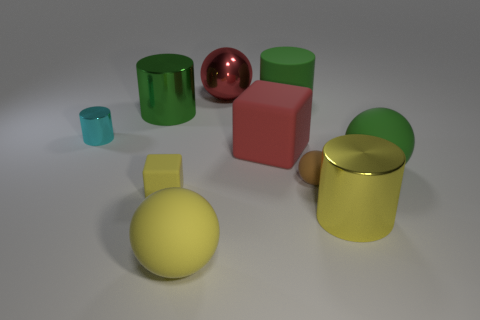Subtract 2 cylinders. How many cylinders are left? 2 Subtract all blue cylinders. Subtract all blue balls. How many cylinders are left? 4 Subtract all cubes. How many objects are left? 8 Add 4 tiny yellow objects. How many tiny yellow objects exist? 5 Subtract 1 yellow cubes. How many objects are left? 9 Subtract all green things. Subtract all yellow rubber things. How many objects are left? 5 Add 2 big red blocks. How many big red blocks are left? 3 